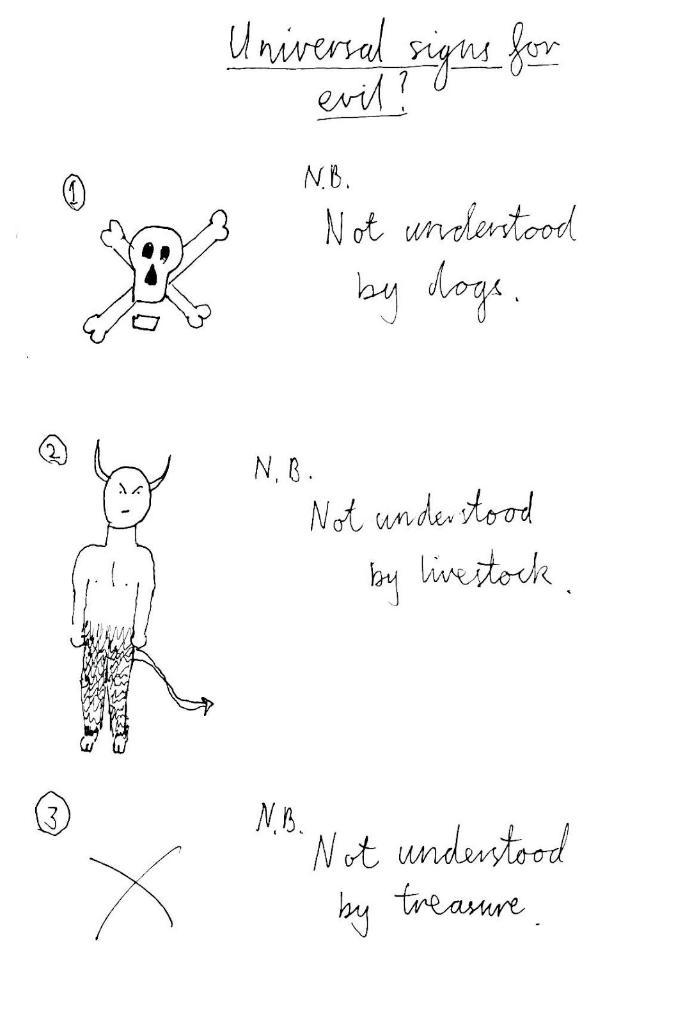What can be found on the page in the image? There are symbols and text on the page. Can you describe the symbols on the page? Unfortunately, the specific symbols cannot be described without more information. What type of content is included in the text on the page? The content of the text cannot be determined without more information. What sound does the whistle make in the image? There is no whistle present in the image. Can you describe the wing of the bird in the image? There is no bird or wing present in the image. 